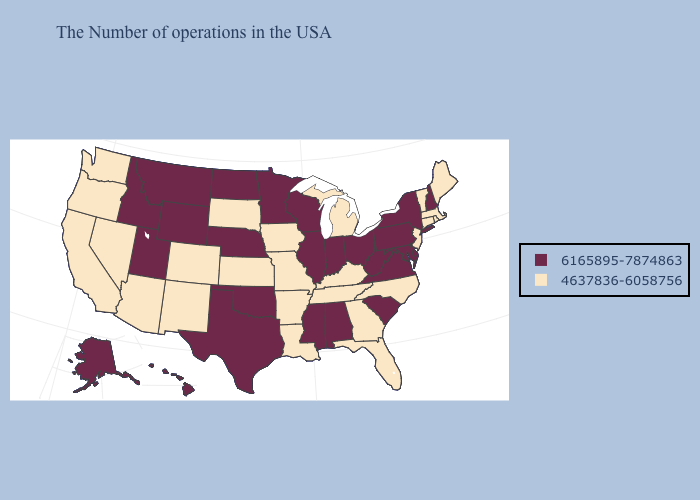What is the value of Nebraska?
Give a very brief answer. 6165895-7874863. Among the states that border Oklahoma , which have the lowest value?
Quick response, please. Missouri, Arkansas, Kansas, Colorado, New Mexico. What is the lowest value in states that border Indiana?
Give a very brief answer. 4637836-6058756. Does New York have the highest value in the USA?
Be succinct. Yes. What is the value of Oregon?
Short answer required. 4637836-6058756. What is the highest value in the MidWest ?
Write a very short answer. 6165895-7874863. What is the value of New Hampshire?
Keep it brief. 6165895-7874863. Which states have the lowest value in the MidWest?
Give a very brief answer. Michigan, Missouri, Iowa, Kansas, South Dakota. Does New Jersey have the highest value in the USA?
Be succinct. No. Which states have the lowest value in the Northeast?
Concise answer only. Maine, Massachusetts, Rhode Island, Vermont, Connecticut, New Jersey. What is the value of Nevada?
Write a very short answer. 4637836-6058756. Name the states that have a value in the range 6165895-7874863?
Give a very brief answer. New Hampshire, New York, Delaware, Maryland, Pennsylvania, Virginia, South Carolina, West Virginia, Ohio, Indiana, Alabama, Wisconsin, Illinois, Mississippi, Minnesota, Nebraska, Oklahoma, Texas, North Dakota, Wyoming, Utah, Montana, Idaho, Alaska, Hawaii. What is the value of Indiana?
Give a very brief answer. 6165895-7874863. Does New Jersey have the same value as Wyoming?
Quick response, please. No. 